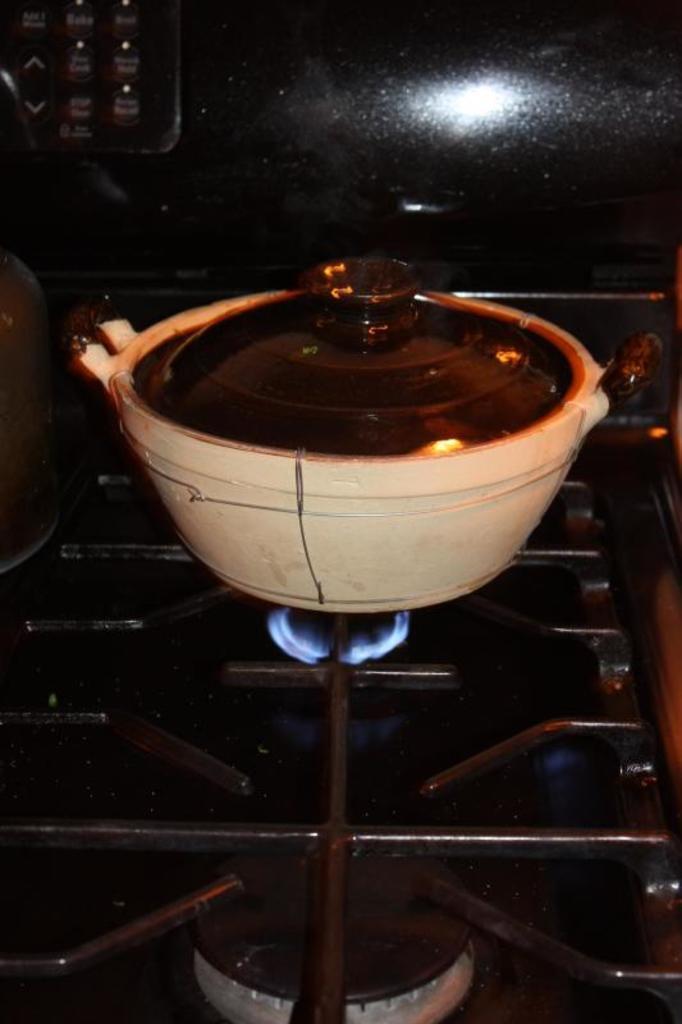Can you describe this image briefly? In this image I can see the gas stove and black colored grill on the gas stove. On it I can see a white and black colored bowl. I can see the black colored background and few buttons. 